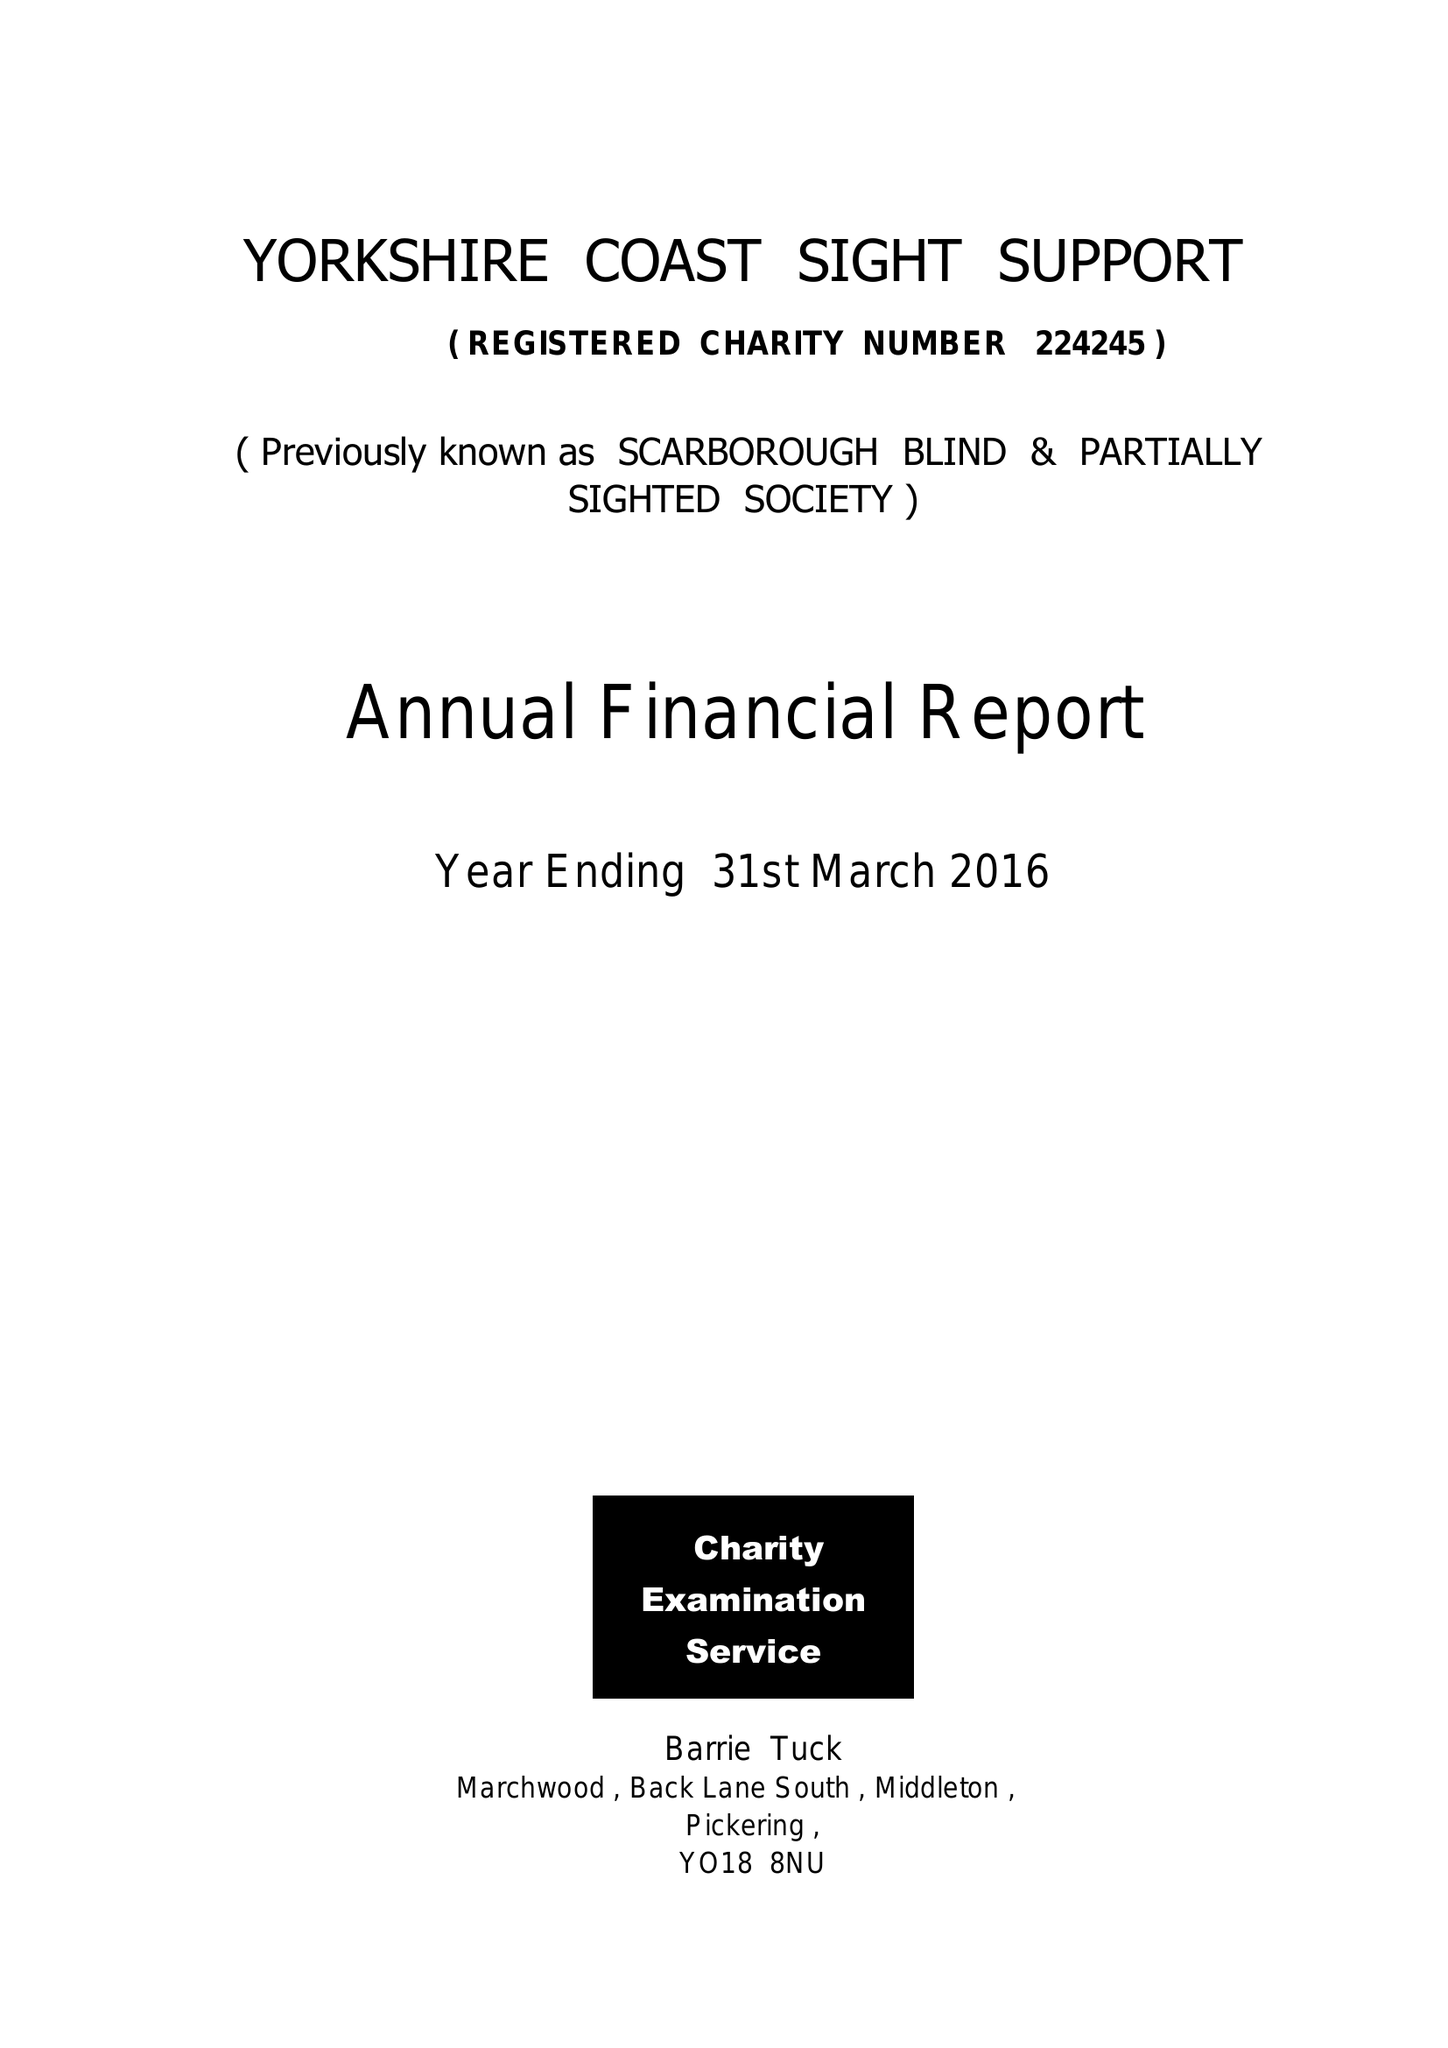What is the value for the report_date?
Answer the question using a single word or phrase. 2015-03-31 